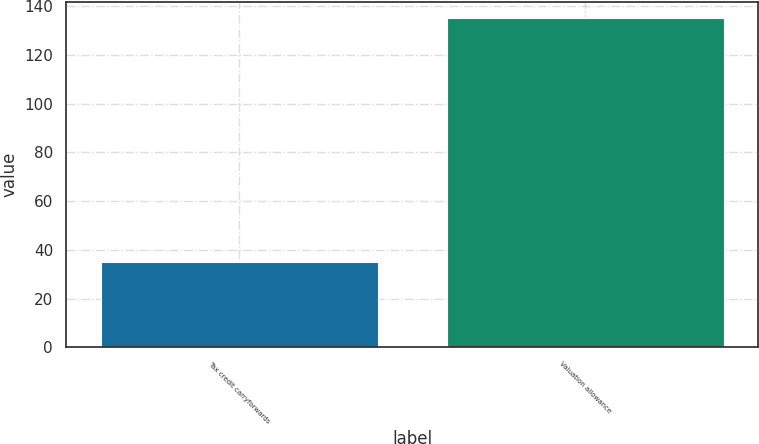<chart> <loc_0><loc_0><loc_500><loc_500><bar_chart><fcel>Tax credit carryforwards<fcel>Valuation allowance<nl><fcel>35<fcel>135<nl></chart> 